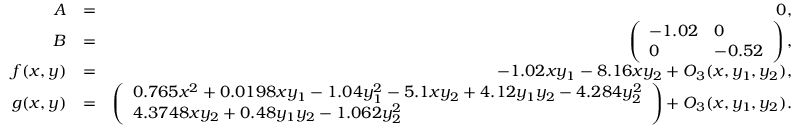Convert formula to latex. <formula><loc_0><loc_0><loc_500><loc_500>\begin{array} { r l r } { A } & { = } & { 0 , } \\ { B } & { = } & { \left ( \begin{array} { l l } { - 1 . 0 2 } & { 0 } \\ { 0 } & { - 0 . 5 2 } \end{array} \right ) , } \\ { f ( x , y ) } & { = } & { - 1 . 0 2 x y _ { 1 } - 8 . 1 6 x y _ { 2 } + O _ { 3 } ( x , y _ { 1 } , y _ { 2 } ) , } \\ { g ( x , y ) } & { = } & { \left ( \begin{array} { l } { 0 . 7 6 5 x ^ { 2 } + 0 . 0 1 9 8 x y _ { 1 } - 1 . 0 4 y _ { 1 } ^ { 2 } - 5 . 1 x y _ { 2 } + 4 . 1 2 y _ { 1 } y _ { 2 } - 4 . 2 8 4 y _ { 2 } ^ { 2 } } \\ { 4 . 3 7 4 8 x y _ { 2 } + 0 . 4 8 y _ { 1 } y _ { 2 } - 1 . 0 6 2 y _ { 2 } ^ { 2 } } \end{array} \right ) + O _ { 3 } ( x , y _ { 1 } , y _ { 2 } ) . } \end{array}</formula> 